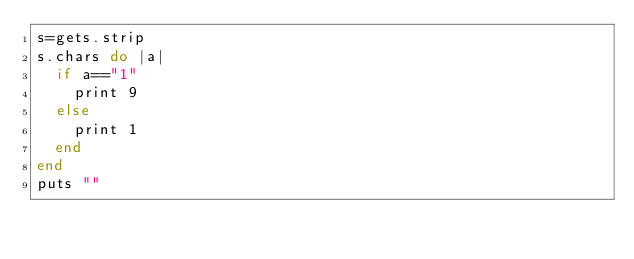Convert code to text. <code><loc_0><loc_0><loc_500><loc_500><_Ruby_>s=gets.strip
s.chars do |a|
  if a=="1"
    print 9
  else
    print 1
  end
end
puts ""</code> 